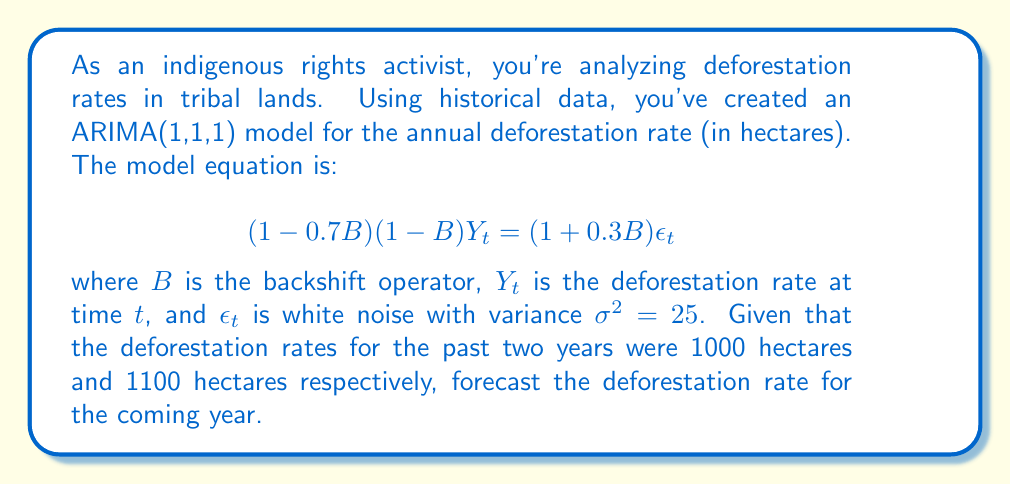Provide a solution to this math problem. To solve this problem, we'll follow these steps:

1) First, let's expand the ARIMA(1,1,1) model equation:
   $$(1 - 0.7B)(1 - B)Y_t = (1 + 0.3B)\epsilon_t$$
   $(1 - B - 0.7B + 0.7B^2)Y_t = (1 + 0.3B)\epsilon_t$
   $Y_t - Y_{t-1} - 0.7Y_{t-1} + 0.7Y_{t-2} = \epsilon_t + 0.3\epsilon_{t-1}$

2) Rearrange to isolate $Y_t$:
   $Y_t = Y_{t-1} + 0.7Y_{t-1} - 0.7Y_{t-2} + \epsilon_t + 0.3\epsilon_{t-1}$
   $Y_t = 1.7Y_{t-1} - 0.7Y_{t-2} + \epsilon_t + 0.3\epsilon_{t-1}$

3) For forecasting, we set future error terms to their expected value, which is 0:
   $\hat{Y}_t = 1.7Y_{t-1} - 0.7Y_{t-2}$

4) We're given $Y_{t-1} = 1100$ and $Y_{t-2} = 1000$. Let's substitute these values:
   $\hat{Y}_t = 1.7(1100) - 0.7(1000)$
   $\hat{Y}_t = 1870 - 700$
   $\hat{Y}_t = 1170$

Therefore, the forecast for the coming year's deforestation rate is 1170 hectares.

5) To calculate the forecast error variance, we use the formula:
   $Var(e_t(1)) = \sigma^2(1 + \theta_1^2) = 25(1 + 0.3^2) = 25(1.09) = 27.25$

   The standard error of the forecast is $\sqrt{27.25} \approx 5.22$ hectares.
Answer: The forecast for the deforestation rate in the coming year is 1170 hectares, with a standard error of approximately 5.22 hectares. 